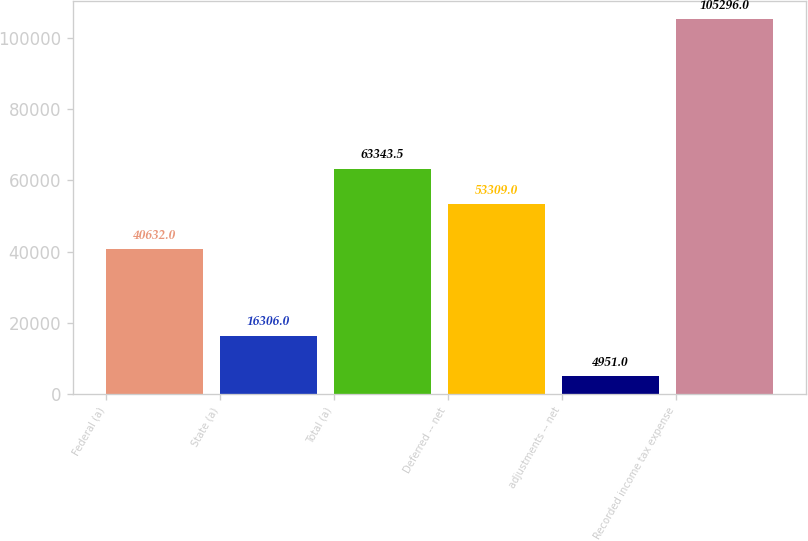Convert chart to OTSL. <chart><loc_0><loc_0><loc_500><loc_500><bar_chart><fcel>Federal (a)<fcel>State (a)<fcel>Total (a)<fcel>Deferred -- net<fcel>adjustments -- net<fcel>Recorded income tax expense<nl><fcel>40632<fcel>16306<fcel>63343.5<fcel>53309<fcel>4951<fcel>105296<nl></chart> 